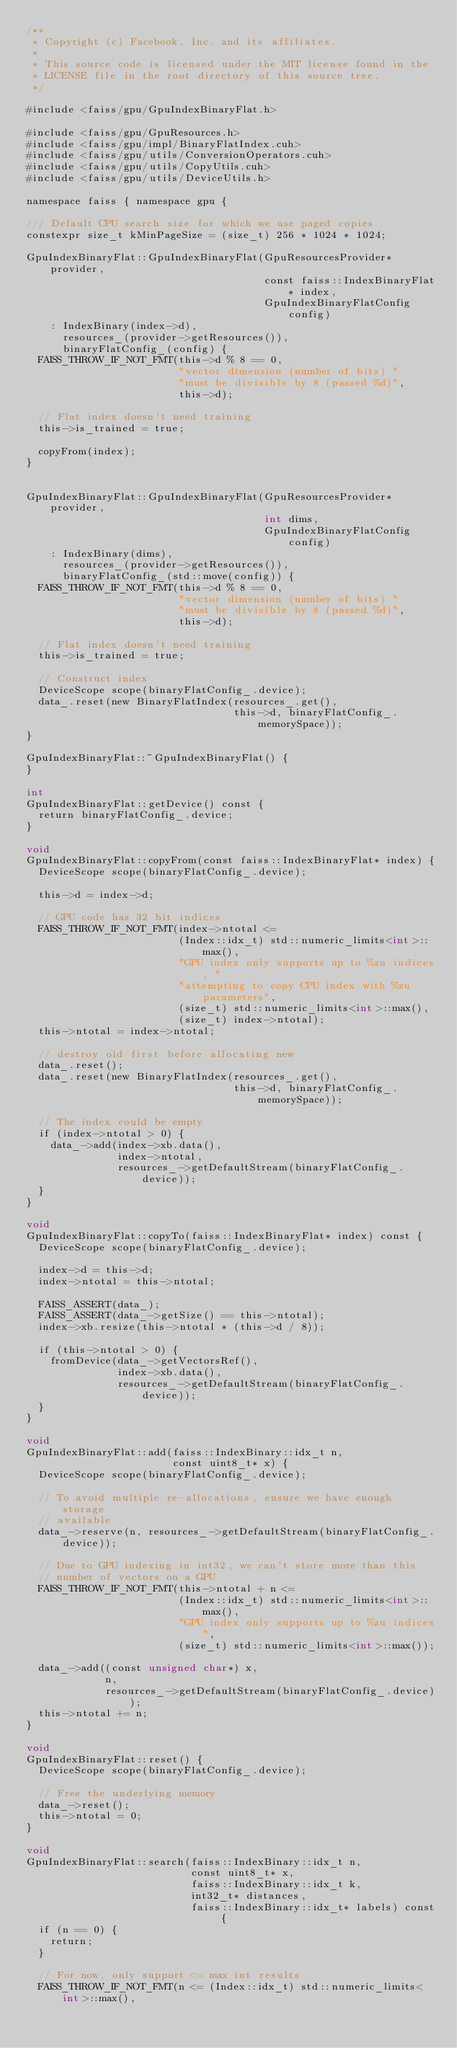<code> <loc_0><loc_0><loc_500><loc_500><_Cuda_>/**
 * Copyright (c) Facebook, Inc. and its affiliates.
 *
 * This source code is licensed under the MIT license found in the
 * LICENSE file in the root directory of this source tree.
 */

#include <faiss/gpu/GpuIndexBinaryFlat.h>

#include <faiss/gpu/GpuResources.h>
#include <faiss/gpu/impl/BinaryFlatIndex.cuh>
#include <faiss/gpu/utils/ConversionOperators.cuh>
#include <faiss/gpu/utils/CopyUtils.cuh>
#include <faiss/gpu/utils/DeviceUtils.h>

namespace faiss { namespace gpu {

/// Default CPU search size for which we use paged copies
constexpr size_t kMinPageSize = (size_t) 256 * 1024 * 1024;

GpuIndexBinaryFlat::GpuIndexBinaryFlat(GpuResourcesProvider* provider,
                                       const faiss::IndexBinaryFlat* index,
                                       GpuIndexBinaryFlatConfig config)
    : IndexBinary(index->d),
      resources_(provider->getResources()),
      binaryFlatConfig_(config) {
  FAISS_THROW_IF_NOT_FMT(this->d % 8 == 0,
                         "vector dimension (number of bits) "
                         "must be divisible by 8 (passed %d)",
                         this->d);

  // Flat index doesn't need training
  this->is_trained = true;

  copyFrom(index);
}


GpuIndexBinaryFlat::GpuIndexBinaryFlat(GpuResourcesProvider* provider,
                                       int dims,
                                       GpuIndexBinaryFlatConfig config)
    : IndexBinary(dims),
      resources_(provider->getResources()),
      binaryFlatConfig_(std::move(config)) {
  FAISS_THROW_IF_NOT_FMT(this->d % 8 == 0,
                         "vector dimension (number of bits) "
                         "must be divisible by 8 (passed %d)",
                         this->d);

  // Flat index doesn't need training
  this->is_trained = true;

  // Construct index
  DeviceScope scope(binaryFlatConfig_.device);
  data_.reset(new BinaryFlatIndex(resources_.get(),
                                  this->d, binaryFlatConfig_.memorySpace));
}

GpuIndexBinaryFlat::~GpuIndexBinaryFlat() {
}

int
GpuIndexBinaryFlat::getDevice() const {
  return binaryFlatConfig_.device;
}

void
GpuIndexBinaryFlat::copyFrom(const faiss::IndexBinaryFlat* index) {
  DeviceScope scope(binaryFlatConfig_.device);

  this->d = index->d;

  // GPU code has 32 bit indices
  FAISS_THROW_IF_NOT_FMT(index->ntotal <=
                         (Index::idx_t) std::numeric_limits<int>::max(),
                         "GPU index only supports up to %zu indices; "
                         "attempting to copy CPU index with %zu parameters",
                         (size_t) std::numeric_limits<int>::max(),
                         (size_t) index->ntotal);
  this->ntotal = index->ntotal;

  // destroy old first before allocating new
  data_.reset();
  data_.reset(new BinaryFlatIndex(resources_.get(),
                                  this->d, binaryFlatConfig_.memorySpace));

  // The index could be empty
  if (index->ntotal > 0) {
    data_->add(index->xb.data(),
               index->ntotal,
               resources_->getDefaultStream(binaryFlatConfig_.device));
  }
}

void
GpuIndexBinaryFlat::copyTo(faiss::IndexBinaryFlat* index) const {
  DeviceScope scope(binaryFlatConfig_.device);

  index->d = this->d;
  index->ntotal = this->ntotal;

  FAISS_ASSERT(data_);
  FAISS_ASSERT(data_->getSize() == this->ntotal);
  index->xb.resize(this->ntotal * (this->d / 8));

  if (this->ntotal > 0) {
    fromDevice(data_->getVectorsRef(),
               index->xb.data(),
               resources_->getDefaultStream(binaryFlatConfig_.device));
  }
}

void
GpuIndexBinaryFlat::add(faiss::IndexBinary::idx_t n,
                        const uint8_t* x) {
  DeviceScope scope(binaryFlatConfig_.device);

  // To avoid multiple re-allocations, ensure we have enough storage
  // available
  data_->reserve(n, resources_->getDefaultStream(binaryFlatConfig_.device));

  // Due to GPU indexing in int32, we can't store more than this
  // number of vectors on a GPU
  FAISS_THROW_IF_NOT_FMT(this->ntotal + n <=
                         (Index::idx_t) std::numeric_limits<int>::max(),
                         "GPU index only supports up to %zu indices",
                         (size_t) std::numeric_limits<int>::max());

  data_->add((const unsigned char*) x,
             n,
             resources_->getDefaultStream(binaryFlatConfig_.device));
  this->ntotal += n;
}

void
GpuIndexBinaryFlat::reset() {
  DeviceScope scope(binaryFlatConfig_.device);

  // Free the underlying memory
  data_->reset();
  this->ntotal = 0;
}

void
GpuIndexBinaryFlat::search(faiss::IndexBinary::idx_t n,
                           const uint8_t* x,
                           faiss::IndexBinary::idx_t k,
                           int32_t* distances,
                           faiss::IndexBinary::idx_t* labels) const {
  if (n == 0) {
    return;
  }

  // For now, only support <= max int results
  FAISS_THROW_IF_NOT_FMT(n <= (Index::idx_t) std::numeric_limits<int>::max(),</code> 